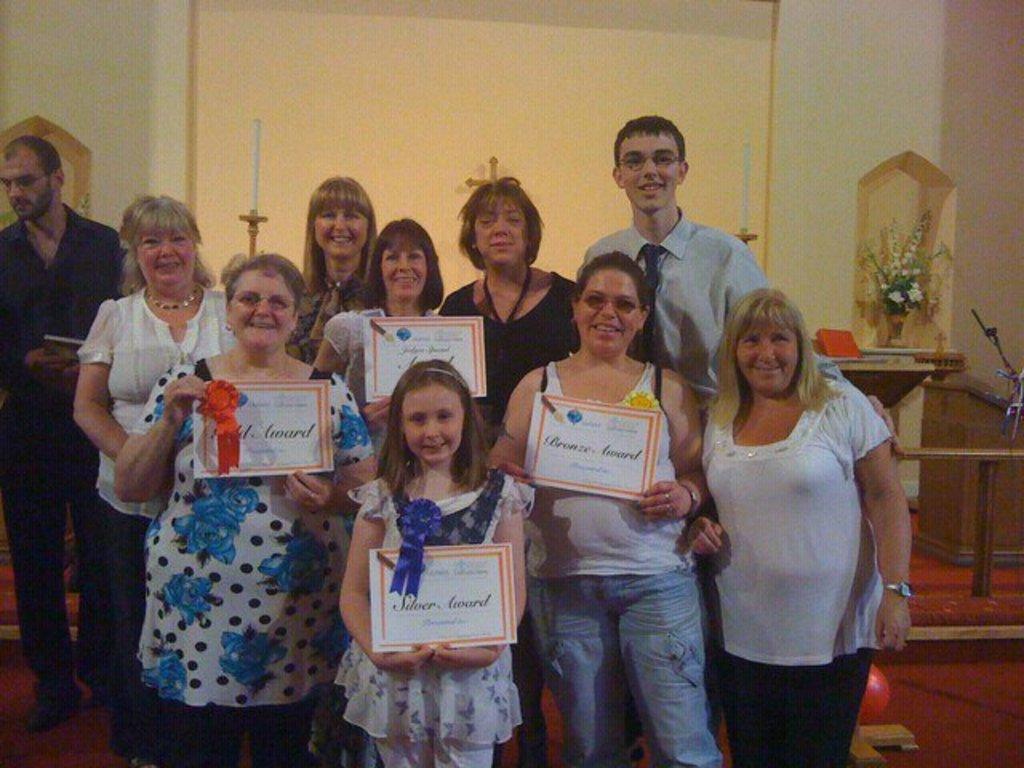In one or two sentences, can you explain what this image depicts? This is an inside view. Here I can see few people standing, smiling and giving pose for the picture. In the front four people are holding the certificates in their hands. In the background, I can see the wall and a table and also I can see a flower vase. 